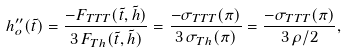<formula> <loc_0><loc_0><loc_500><loc_500>h _ { o } ^ { \prime \prime } ( \tilde { t } ) = \frac { - F _ { T T T } ( \tilde { t } , \tilde { h } ) } { 3 \, F _ { T h } ( \tilde { t } , \tilde { h } ) } = \frac { - \sigma _ { T T T } ( \pi ) } { 3 \, \sigma _ { T h } ( \pi ) } = \frac { - \sigma _ { T T T } ( \pi ) } { 3 \, \rho / 2 } ,</formula> 